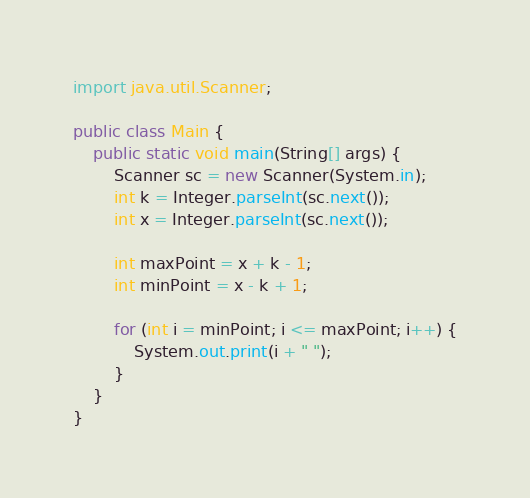Convert code to text. <code><loc_0><loc_0><loc_500><loc_500><_Java_>import java.util.Scanner;

public class Main {
    public static void main(String[] args) {
        Scanner sc = new Scanner(System.in);
        int k = Integer.parseInt(sc.next());
        int x = Integer.parseInt(sc.next());

        int maxPoint = x + k - 1;
        int minPoint = x - k + 1;

        for (int i = minPoint; i <= maxPoint; i++) {
            System.out.print(i + " ");
        }
    }
}</code> 